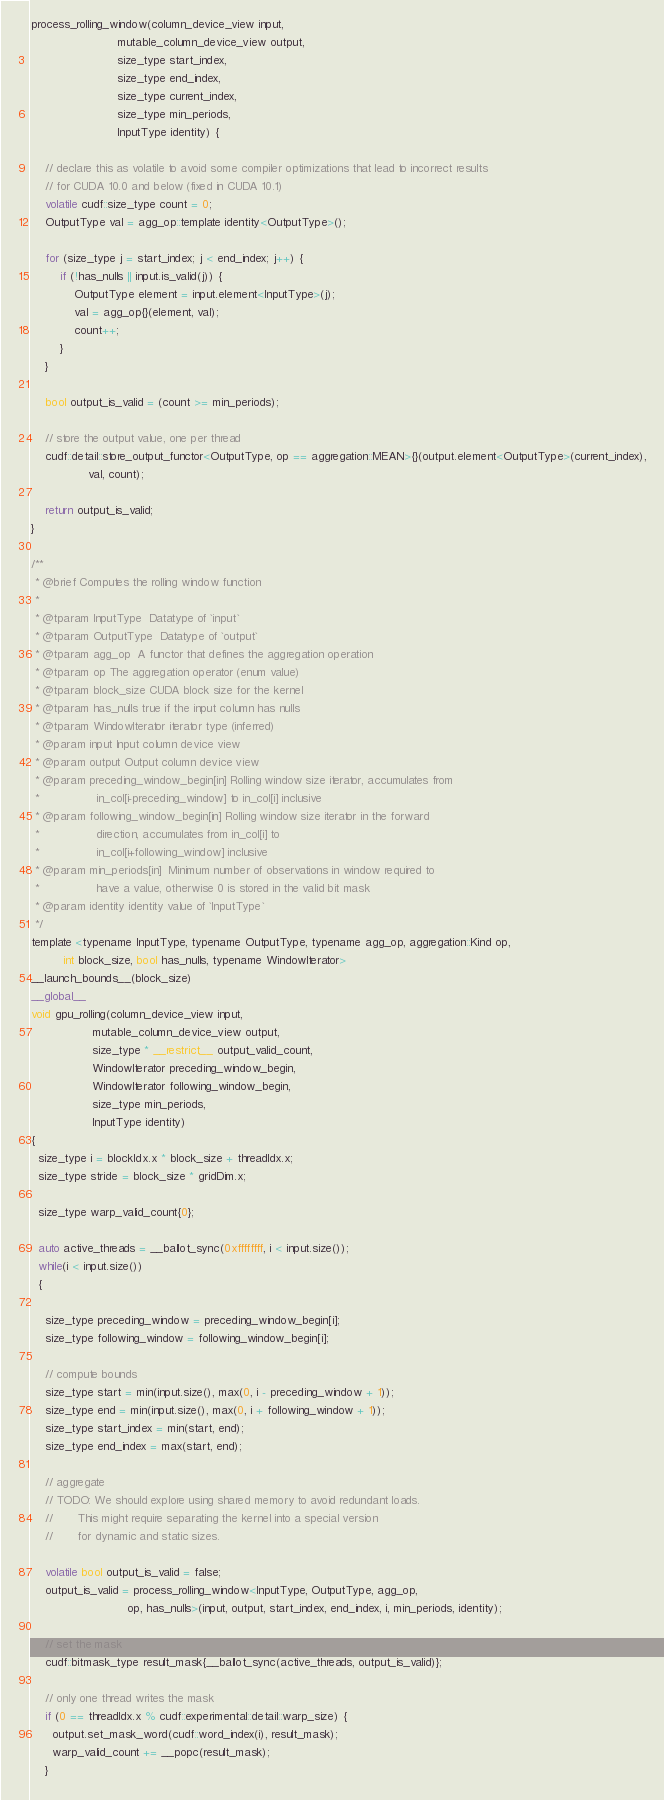<code> <loc_0><loc_0><loc_500><loc_500><_Cuda_>process_rolling_window(column_device_view input,
                        mutable_column_device_view output,
                        size_type start_index,
                        size_type end_index,
                        size_type current_index,
                        size_type min_periods,
                        InputType identity) {

    // declare this as volatile to avoid some compiler optimizations that lead to incorrect results
    // for CUDA 10.0 and below (fixed in CUDA 10.1)
    volatile cudf::size_type count = 0;
    OutputType val = agg_op::template identity<OutputType>();

    for (size_type j = start_index; j < end_index; j++) {
        if (!has_nulls || input.is_valid(j)) {
            OutputType element = input.element<InputType>(j);
            val = agg_op{}(element, val);
            count++;
        }
    }

    bool output_is_valid = (count >= min_periods);

    // store the output value, one per thread
    cudf::detail::store_output_functor<OutputType, op == aggregation::MEAN>{}(output.element<OutputType>(current_index),
                val, count);

    return output_is_valid;
}

/**
 * @brief Computes the rolling window function
 *
 * @tparam InputType  Datatype of `input`
 * @tparam OutputType  Datatype of `output`
 * @tparam agg_op  A functor that defines the aggregation operation
 * @tparam op The aggregation operator (enum value)
 * @tparam block_size CUDA block size for the kernel
 * @tparam has_nulls true if the input column has nulls
 * @tparam WindowIterator iterator type (inferred)
 * @param input Input column device view
 * @param output Output column device view
 * @param preceding_window_begin[in] Rolling window size iterator, accumulates from
 *                in_col[i-preceding_window] to in_col[i] inclusive
 * @param following_window_begin[in] Rolling window size iterator in the forward
 *                direction, accumulates from in_col[i] to
 *                in_col[i+following_window] inclusive
 * @param min_periods[in]  Minimum number of observations in window required to
 *                have a value, otherwise 0 is stored in the valid bit mask
 * @param identity identity value of `InputType`
 */
template <typename InputType, typename OutputType, typename agg_op, aggregation::Kind op, 
         int block_size, bool has_nulls, typename WindowIterator>
__launch_bounds__(block_size)
__global__
void gpu_rolling(column_device_view input,
                 mutable_column_device_view output,
                 size_type * __restrict__ output_valid_count,
                 WindowIterator preceding_window_begin,
                 WindowIterator following_window_begin,
                 size_type min_periods,
                 InputType identity)
{
  size_type i = blockIdx.x * block_size + threadIdx.x;
  size_type stride = block_size * gridDim.x;

  size_type warp_valid_count{0};

  auto active_threads = __ballot_sync(0xffffffff, i < input.size());
  while(i < input.size())
  {

    size_type preceding_window = preceding_window_begin[i];
    size_type following_window = following_window_begin[i];

    // compute bounds
    size_type start = min(input.size(), max(0, i - preceding_window + 1));
    size_type end = min(input.size(), max(0, i + following_window + 1));
    size_type start_index = min(start, end);
    size_type end_index = max(start, end);

    // aggregate
    // TODO: We should explore using shared memory to avoid redundant loads.
    //       This might require separating the kernel into a special version
    //       for dynamic and static sizes.

    volatile bool output_is_valid = false;
    output_is_valid = process_rolling_window<InputType, OutputType, agg_op,
                           op, has_nulls>(input, output, start_index, end_index, i, min_periods, identity); 

    // set the mask
    cudf::bitmask_type result_mask{__ballot_sync(active_threads, output_is_valid)};

    // only one thread writes the mask
    if (0 == threadIdx.x % cudf::experimental::detail::warp_size) {
      output.set_mask_word(cudf::word_index(i), result_mask);
      warp_valid_count += __popc(result_mask);
    }
</code> 